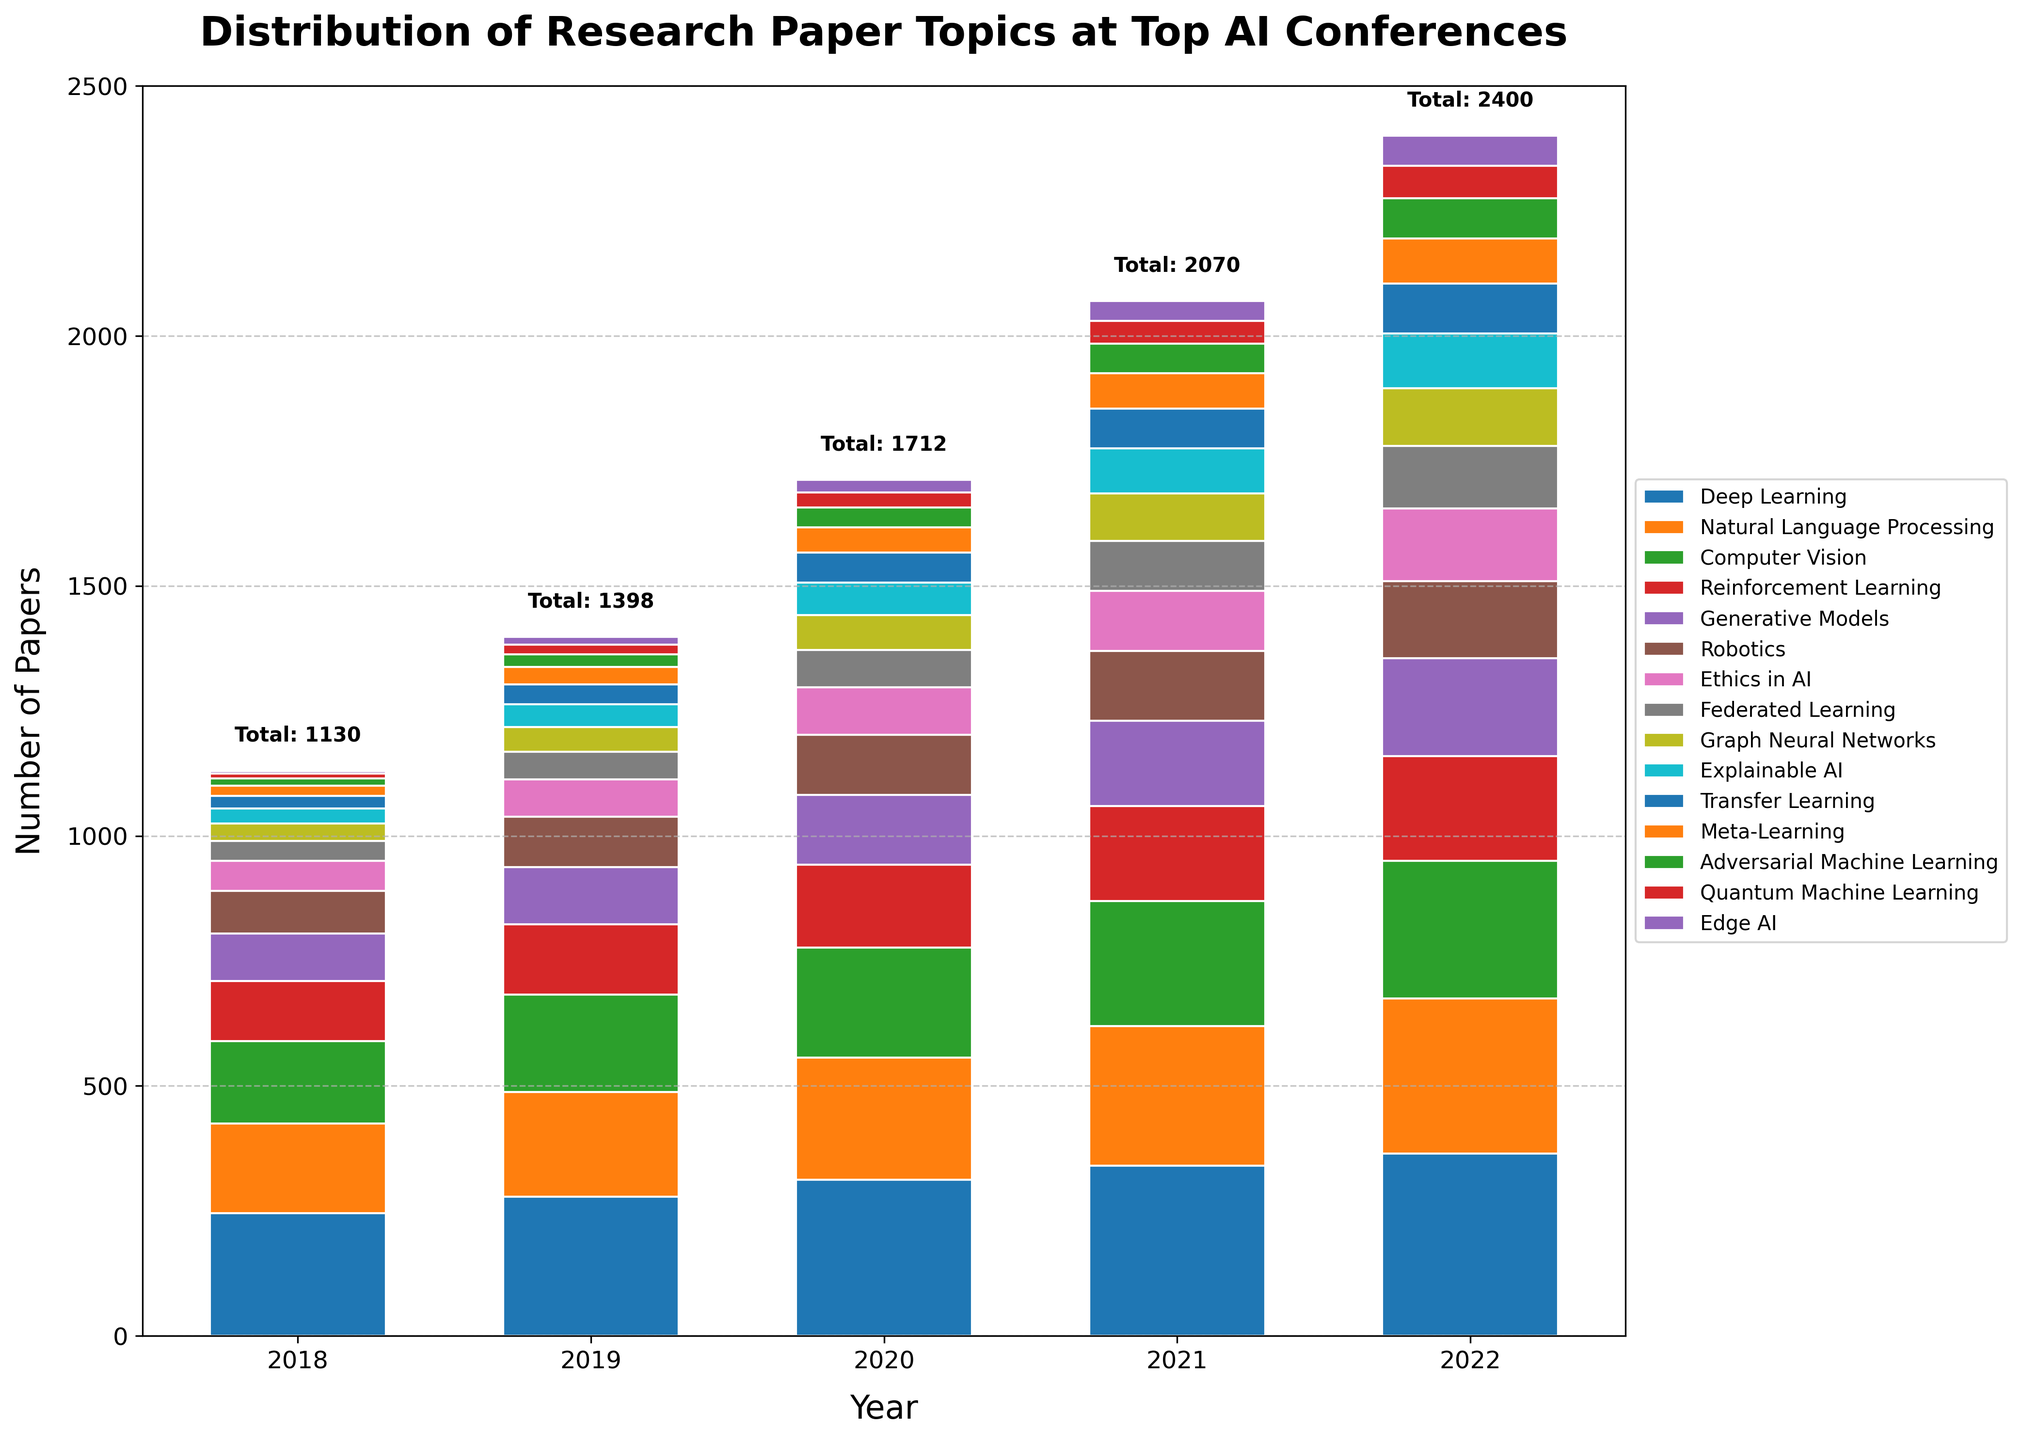What is the total number of papers in 2021? To find the total number of papers in 2021, sum the number of papers from each topic for that year. That is 340 (Deep Learning) + 280 (Natural Language Processing) + 250 (Computer Vision) + 190 (Reinforcement Learning) + 170 (Generative Models) + 140 (Robotics) + 120 (Ethics in AI) + 100 (Federated Learning) + 95 (Graph Neural Networks) + 90 (Explainable AI) + 80 (Transfer Learning) + 70 (Meta-Learning) + 60 (Adversarial Machine Learning) + 45 (Quantum Machine Learning) + 40 (Edge AI) = 2070.
Answer: 2070 Which topic has the second highest number of papers in 2020? From the figure, the bars for each topic can be compared for the year 2020. Deep Learning has the highest number of 312 papers, and Natural Language Processing has the second highest number of 245 papers.
Answer: Natural Language Processing How many more papers on Deep Learning were published in 2022 compared to 2018? Calculate the difference in the number of Deep Learning papers between 2022 and 2018. That is 365 (2022) - 245 (2018) = 120.
Answer: 120 Which topic has seen the greatest increase in the number of papers from 2018 to 2022? To find the topic with the greatest increase, calculate the difference for each topic between 2018 and 2022. Deep Learning: 365 - 245 = 120, Natural Language Processing: 310 - 180 = 130, Computer Vision: 275 - 165 = 110, Reinforcement Learning: 210 - 120 = 90, Generative Models: 195 - 95 = 100, Robotics: 155 - 85 = 70, Ethics in AI: 145 - 60 = 85, Federated Learning: 125 - 40 = 85, Graph Neural Networks: 115 - 35 = 80, Explainable AI: 110 - 30 = 80, Transfer Learning: 100 - 25 = 75, Meta-Learning: 90 - 20 = 70, Adversarial Machine Learning: 80 - 15 = 65, Quantum Machine Learning: 65 - 10 = 55, Edge AI: 60 - 5 = 55. The greatest increase is for Natural Language Processing with an increase of 130.
Answer: Natural Language Processing What is the average number of papers published per year for Explainable AI from 2018 to 2022? To find the average, first sum the number of papers each year and then divide by the number of years. Sum: 30 (2018) + 45 (2019) + 65 (2020) + 90 (2021) + 110 (2022) = 340. Average: 340 / 5 = 68.
Answer: 68 In 2019, which two topics have the closest number of papers and what is the difference between them? From the figure, in 2019, Graph Neural Networks have 50 papers and Explainable AI has 45 papers. The difference is 50 - 45 = 5.
Answer: Graph Neural Networks and Explainable AI, 5 What is the difference between the total number of papers presented in 2020 and 2022? Sum the total number of papers for 2020 and 2022 and then find the difference. 2020: 312 + 245 + 220 + 165 + 140 + 120 + 95 + 75 + 70 + 65 + 60 + 50 + 40 + 30 + 25 = 1972. 2022: 365 + 310 + 275 + 210 + 195 + 155 + 145 + 125 + 115 + 110 + 100 + 90 + 80 + 65 + 60 = 2390. Difference: 2390 - 1972 = 418.
Answer: 418 By how much did the number of Adversarial Machine Learning papers increase from 2018 to 2021? Subtract the number of Adversarial Machine Learning papers in 2018 from the number in 2021. That is 60 (2021) - 15 (2018) = 45.
Answer: 45 Was the number of Quantum Machine Learning papers in 2022 greater than or equal to the total number of Explainable AI papers in 2020 and 2021 combined? First, sum the number of Explainable AI papers for 2020 and 2021. That is 65 (2020) + 90 (2021) = 155. Then compare this number to the number of Quantum Machine Learning papers in 2022, which is 65. Since 65 < 155, the number of Quantum Machine Learning papers in 2022 is not greater than or equal to 155.
Answer: No What is the percentage increase in the number of Ethics in AI papers from 2018 to 2022? First, calculate the increase in the number of papers. That is 145 (2022) - 60 (2018) = 85. Next, calculate the percentage increase. That is (85 / 60) * 100 ≈ 141.67%.
Answer: 141.67% 